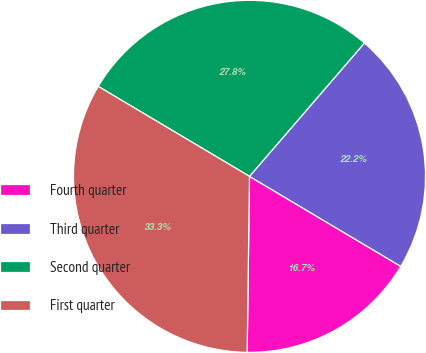Convert chart to OTSL. <chart><loc_0><loc_0><loc_500><loc_500><pie_chart><fcel>Fourth quarter<fcel>Third quarter<fcel>Second quarter<fcel>First quarter<nl><fcel>16.67%<fcel>22.22%<fcel>27.78%<fcel>33.33%<nl></chart> 